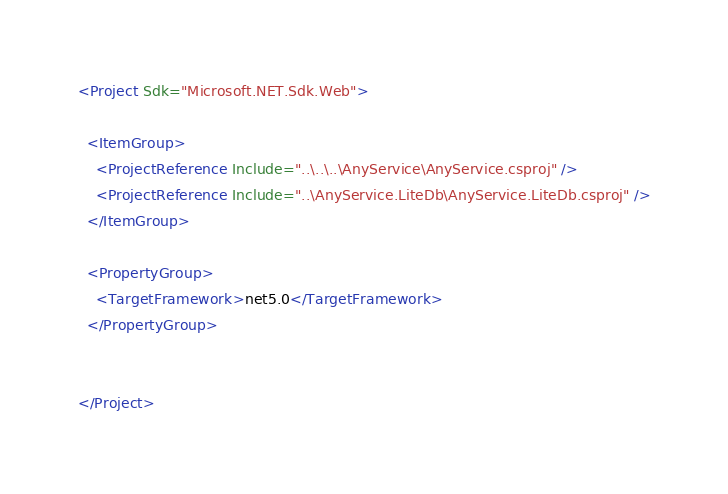Convert code to text. <code><loc_0><loc_0><loc_500><loc_500><_XML_><Project Sdk="Microsoft.NET.Sdk.Web">

  <ItemGroup>
    <ProjectReference Include="..\..\..\AnyService\AnyService.csproj" />
    <ProjectReference Include="..\AnyService.LiteDb\AnyService.LiteDb.csproj" />
  </ItemGroup>

  <PropertyGroup>
    <TargetFramework>net5.0</TargetFramework>
  </PropertyGroup>


</Project>
</code> 